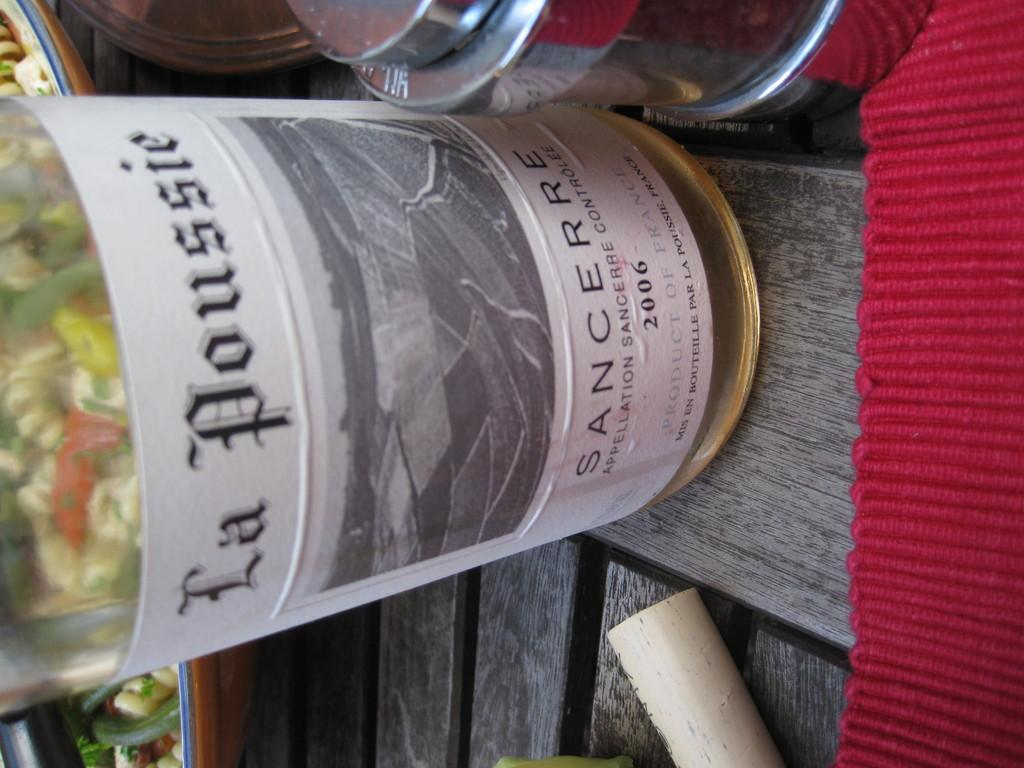Provide a one-sentence caption for the provided image. A bottle is seen sideways on containing La Poussie white wine. 